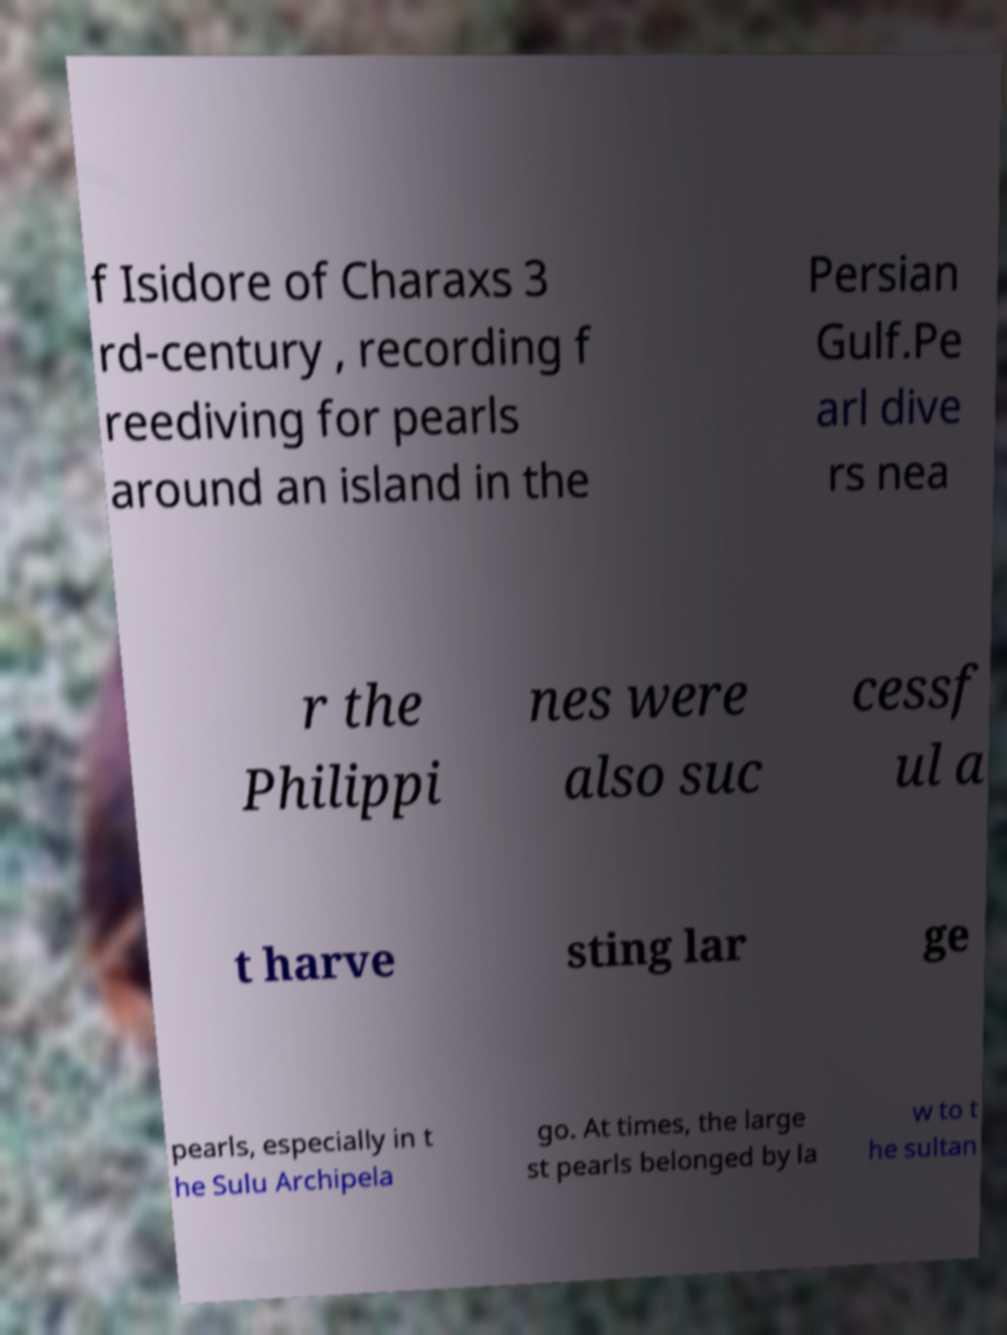Can you read and provide the text displayed in the image?This photo seems to have some interesting text. Can you extract and type it out for me? f Isidore of Charaxs 3 rd-century , recording f reediving for pearls around an island in the Persian Gulf.Pe arl dive rs nea r the Philippi nes were also suc cessf ul a t harve sting lar ge pearls, especially in t he Sulu Archipela go. At times, the large st pearls belonged by la w to t he sultan 